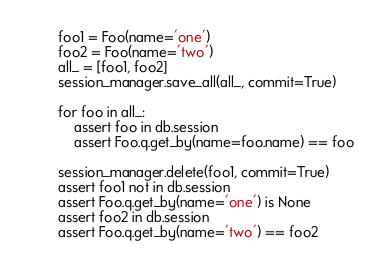<code> <loc_0><loc_0><loc_500><loc_500><_Python_>        foo1 = Foo(name='one')
        foo2 = Foo(name='two')
        all_ = [foo1, foo2]
        session_manager.save_all(all_, commit=True)

        for foo in all_:
            assert foo in db.session
            assert Foo.q.get_by(name=foo.name) == foo

        session_manager.delete(foo1, commit=True)
        assert foo1 not in db.session
        assert Foo.q.get_by(name='one') is None
        assert foo2 in db.session
        assert Foo.q.get_by(name='two') == foo2
</code> 